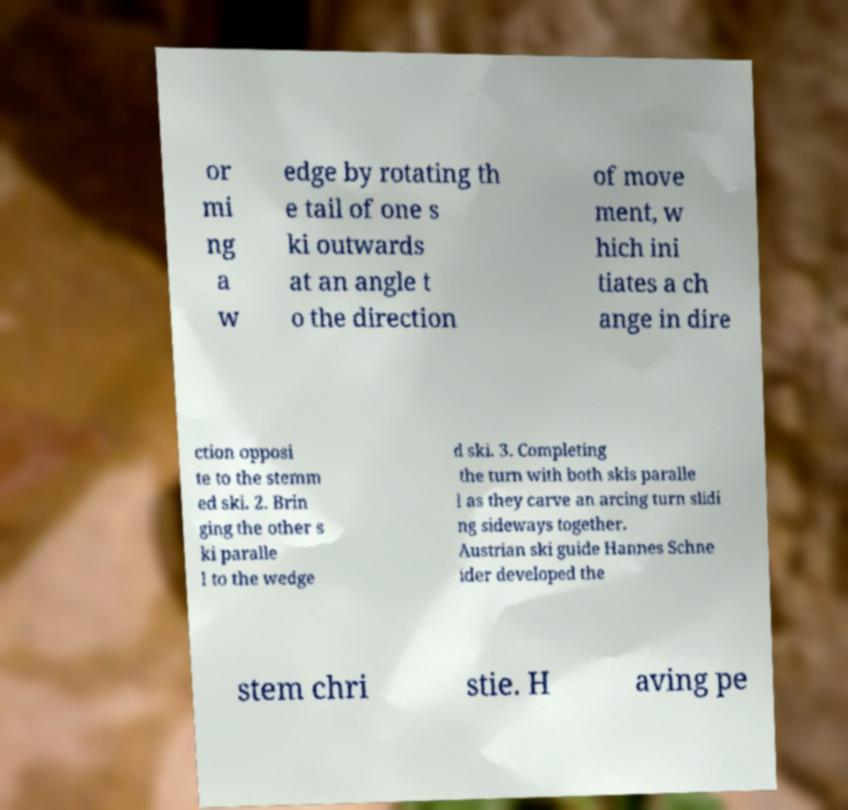Please read and relay the text visible in this image. What does it say? or mi ng a w edge by rotating th e tail of one s ki outwards at an angle t o the direction of move ment, w hich ini tiates a ch ange in dire ction opposi te to the stemm ed ski. 2. Brin ging the other s ki paralle l to the wedge d ski. 3. Completing the turn with both skis paralle l as they carve an arcing turn slidi ng sideways together. Austrian ski guide Hannes Schne ider developed the stem chri stie. H aving pe 